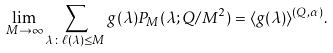<formula> <loc_0><loc_0><loc_500><loc_500>\lim _ { M \to \infty } \sum _ { \lambda \colon \ell ( \lambda ) \leq M } g ( \lambda ) P _ { M } ( \lambda ; Q / M ^ { 2 } ) = \langle g ( \lambda ) \rangle ^ { ( Q , \alpha ) } .</formula> 